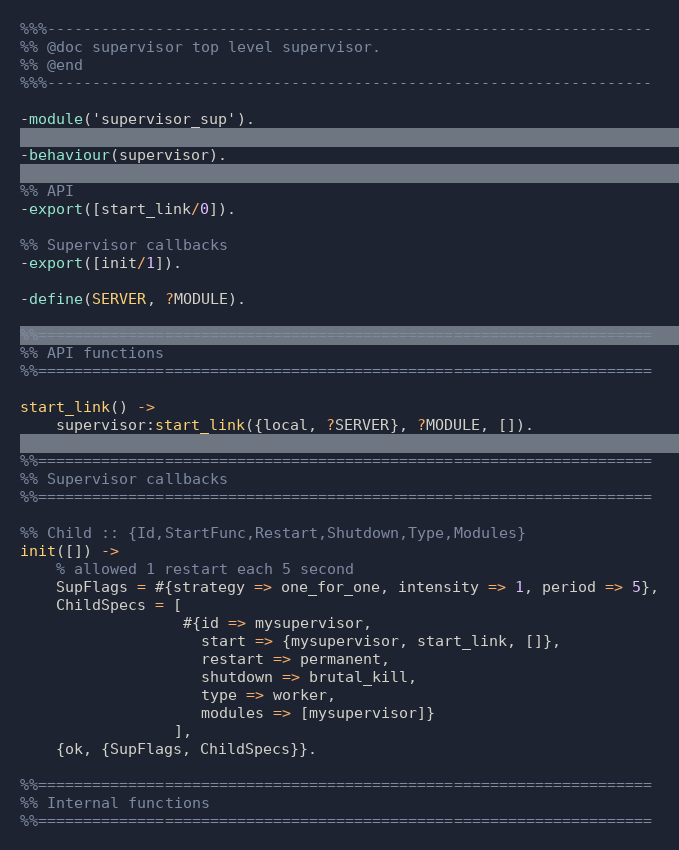<code> <loc_0><loc_0><loc_500><loc_500><_Erlang_>%%%-------------------------------------------------------------------
%% @doc supervisor top level supervisor.
%% @end
%%%-------------------------------------------------------------------

-module('supervisor_sup').

-behaviour(supervisor).

%% API
-export([start_link/0]).

%% Supervisor callbacks
-export([init/1]).

-define(SERVER, ?MODULE).

%%====================================================================
%% API functions
%%====================================================================

start_link() ->
    supervisor:start_link({local, ?SERVER}, ?MODULE, []).

%%====================================================================
%% Supervisor callbacks
%%====================================================================

%% Child :: {Id,StartFunc,Restart,Shutdown,Type,Modules}
init([]) ->
    % allowed 1 restart each 5 second
    SupFlags = #{strategy => one_for_one, intensity => 1, period => 5},
    ChildSpecs = [
                  #{id => mysupervisor,
                    start => {mysupervisor, start_link, []},
                    restart => permanent,
                    shutdown => brutal_kill,
                    type => worker,
                    modules => [mysupervisor]}
                 ],
    {ok, {SupFlags, ChildSpecs}}.

%%====================================================================
%% Internal functions
%%====================================================================
</code> 